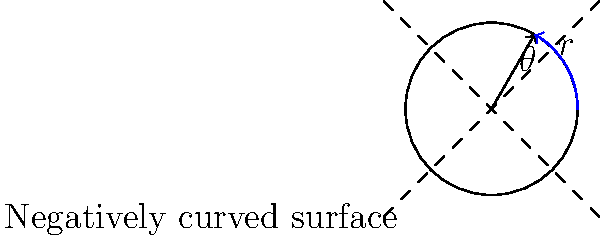On a negatively curved surface, the area of a circle with radius $r$ is given by $A = 4\pi k^2 \sinh^2(\frac{r}{2k})$, where $k$ is a positive constant related to the curvature of the surface. If the area of a circle with radius 3 units is 40π square units, what is the value of $k$ to the nearest tenth? Let's approach this step-by-step:

1) We're given that $A = 4\pi k^2 \sinh^2(\frac{r}{2k})$

2) We know that:
   - The area $A = 40\pi$ square units
   - The radius $r = 3$ units

3) Let's substitute these values into the equation:

   $40\pi = 4\pi k^2 \sinh^2(\frac{3}{2k})$

4) Simplify:

   $10 = k^2 \sinh^2(\frac{3}{2k})$

5) Take the square root of both sides:

   $\sqrt{10} = k \sinh(\frac{3}{2k})$

6) Divide both sides by $k$:

   $\frac{\sqrt{10}}{k} = \sinh(\frac{3}{2k})$

7) Apply the inverse hyperbolic sine (arcsinh) to both sides:

   $\text{arcsinh}(\frac{\sqrt{10}}{k}) = \frac{3}{2k}$

8) Multiply both sides by $2k$:

   $2k \cdot \text{arcsinh}(\frac{\sqrt{10}}{k}) = 3$

9) This equation cannot be solved algebraically. We need to use numerical methods or a graphing calculator to find the value of $k$.

10) Using a numerical solver, we find that $k \approx 1.7$ (to the nearest tenth).
Answer: $k \approx 1.7$ 